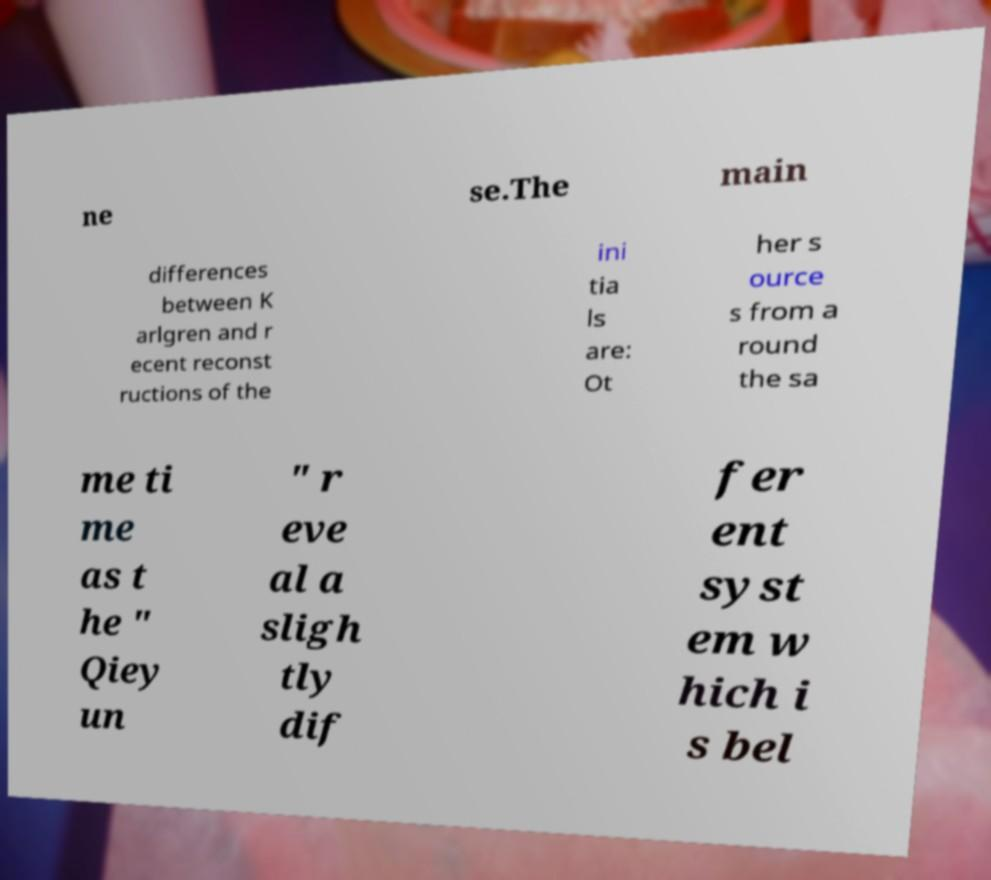There's text embedded in this image that I need extracted. Can you transcribe it verbatim? ne se.The main differences between K arlgren and r ecent reconst ructions of the ini tia ls are: Ot her s ource s from a round the sa me ti me as t he " Qiey un " r eve al a sligh tly dif fer ent syst em w hich i s bel 